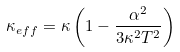<formula> <loc_0><loc_0><loc_500><loc_500>\kappa _ { e f f } = \kappa \left ( 1 - \frac { \alpha ^ { 2 } } { 3 \kappa ^ { 2 } T ^ { 2 } } \right )</formula> 